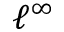<formula> <loc_0><loc_0><loc_500><loc_500>\ell ^ { \infty }</formula> 